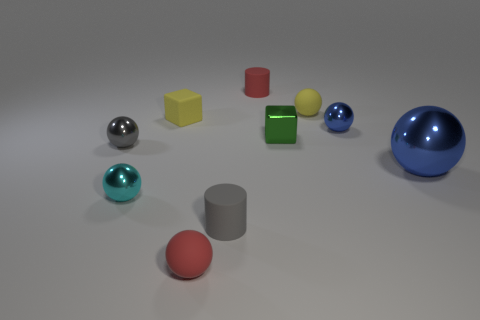Subtract 1 spheres. How many spheres are left? 5 Subtract all red balls. How many balls are left? 5 Subtract all small cyan balls. How many balls are left? 5 Subtract all cyan balls. Subtract all green cubes. How many balls are left? 5 Subtract all balls. How many objects are left? 4 Add 7 blue objects. How many blue objects are left? 9 Add 4 small green objects. How many small green objects exist? 5 Subtract 1 cyan spheres. How many objects are left? 9 Subtract all cyan spheres. Subtract all tiny green rubber blocks. How many objects are left? 9 